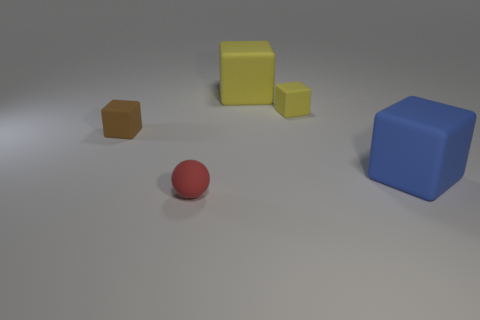Subtract all cyan cubes. Subtract all purple cylinders. How many cubes are left? 4 Add 4 big gray shiny blocks. How many objects exist? 9 Subtract all blocks. How many objects are left? 1 Add 5 small brown matte blocks. How many small brown matte blocks are left? 6 Add 3 tiny gray rubber things. How many tiny gray rubber things exist? 3 Subtract 0 gray cubes. How many objects are left? 5 Subtract all brown objects. Subtract all green cubes. How many objects are left? 4 